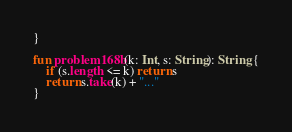Convert code to text. <code><loc_0><loc_0><loc_500><loc_500><_Kotlin_>}

fun problem168b(k: Int, s: String): String {
    if (s.length <= k) return s
    return s.take(k) + "..."
}</code> 